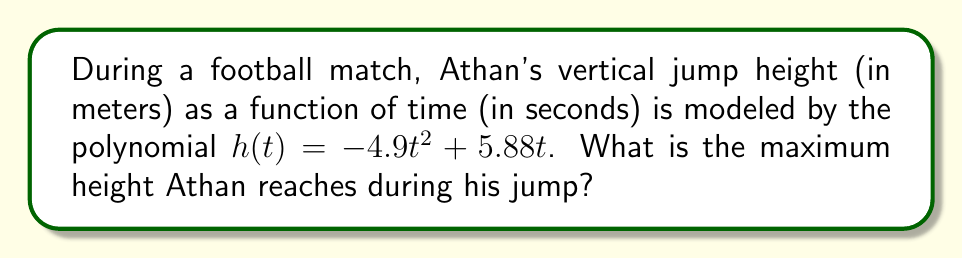Help me with this question. To find the maximum height, we need to follow these steps:

1) The function $h(t) = -4.9t^2 + 5.88t$ is a quadratic function, which forms a parabola when graphed.

2) For a parabola that opens downward (negative coefficient of $t^2$), the maximum point occurs at the vertex.

3) To find the vertex, we use the formula: $t = -\frac{b}{2a}$, where $a$ and $b$ are the coefficients of $t^2$ and $t$ respectively.

4) In this case, $a = -4.9$ and $b = 5.88$

5) $t = -\frac{5.88}{2(-4.9)} = \frac{5.88}{9.8} = 0.6$ seconds

6) To find the maximum height, we substitute this t-value back into the original function:

   $h(0.6) = -4.9(0.6)^2 + 5.88(0.6)$
   
   $= -4.9(0.36) + 3.528$
   
   $= -1.764 + 3.528$
   
   $= 1.764$ meters

Therefore, the maximum height Athan reaches is 1.764 meters.
Answer: 1.764 m 